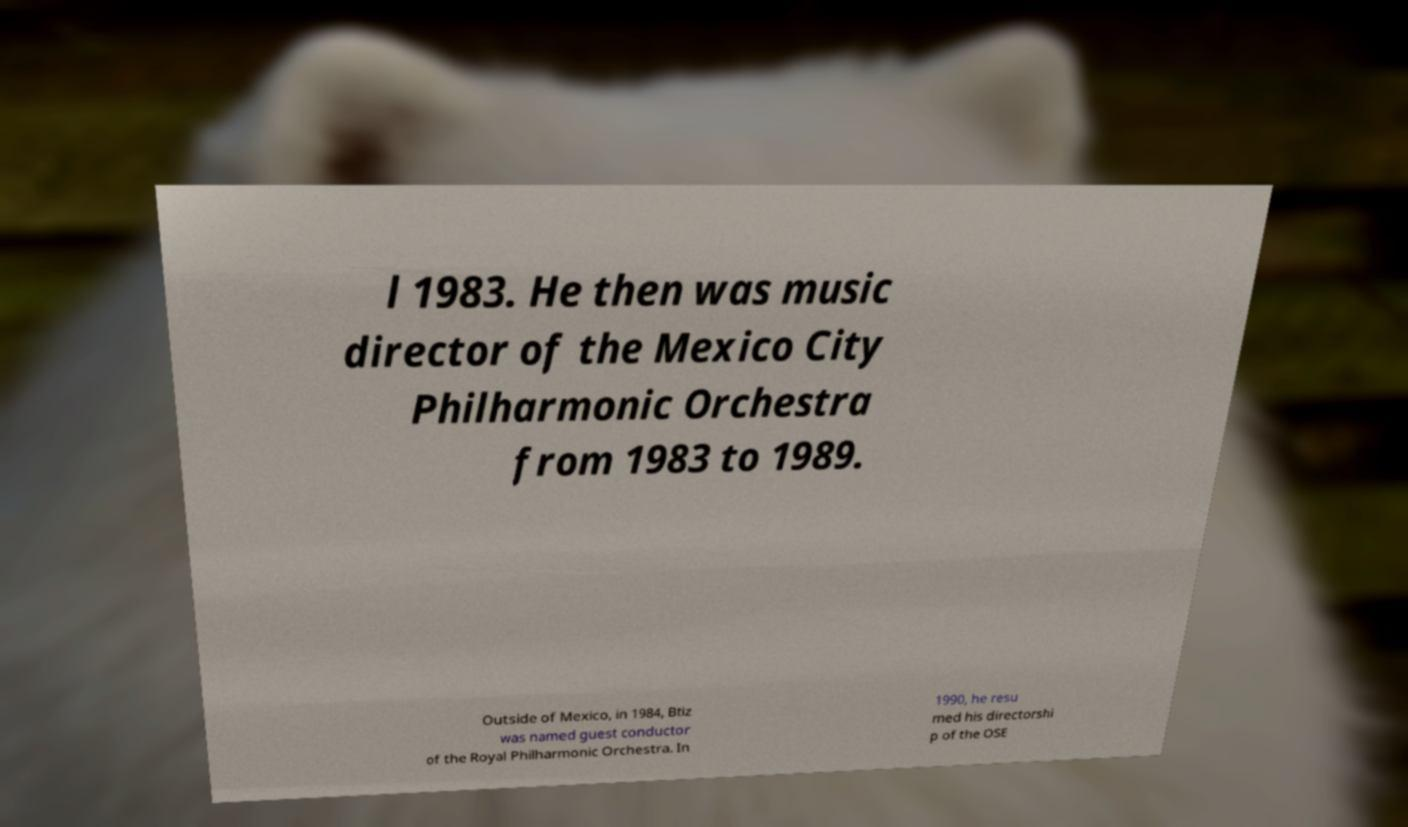Can you read and provide the text displayed in the image?This photo seems to have some interesting text. Can you extract and type it out for me? l 1983. He then was music director of the Mexico City Philharmonic Orchestra from 1983 to 1989. Outside of Mexico, in 1984, Btiz was named guest conductor of the Royal Philharmonic Orchestra. In 1990, he resu med his directorshi p of the OSE 